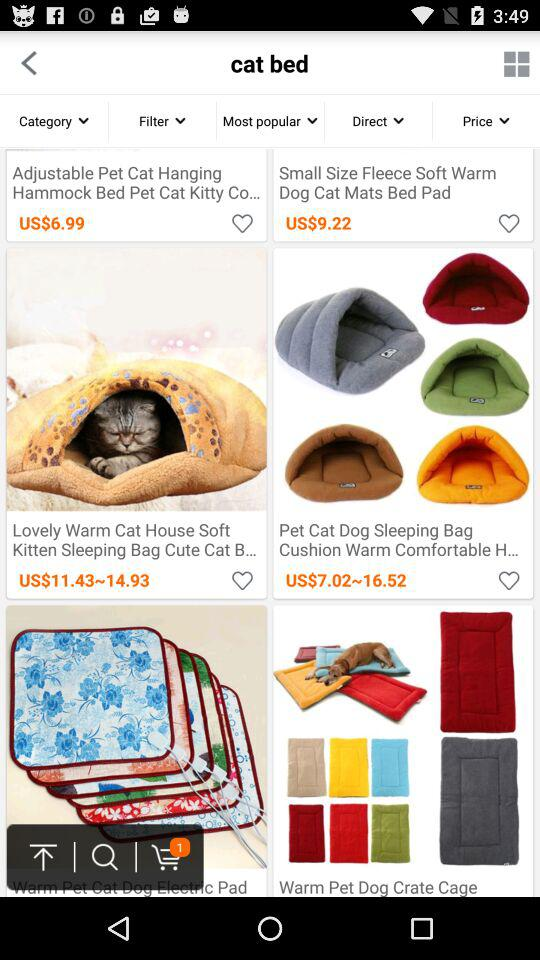What is the cost of "Adjustable Pet Cat Hanging Hammock Bed Pet Cat Kitty Co..."? The cost is US$6.99. 